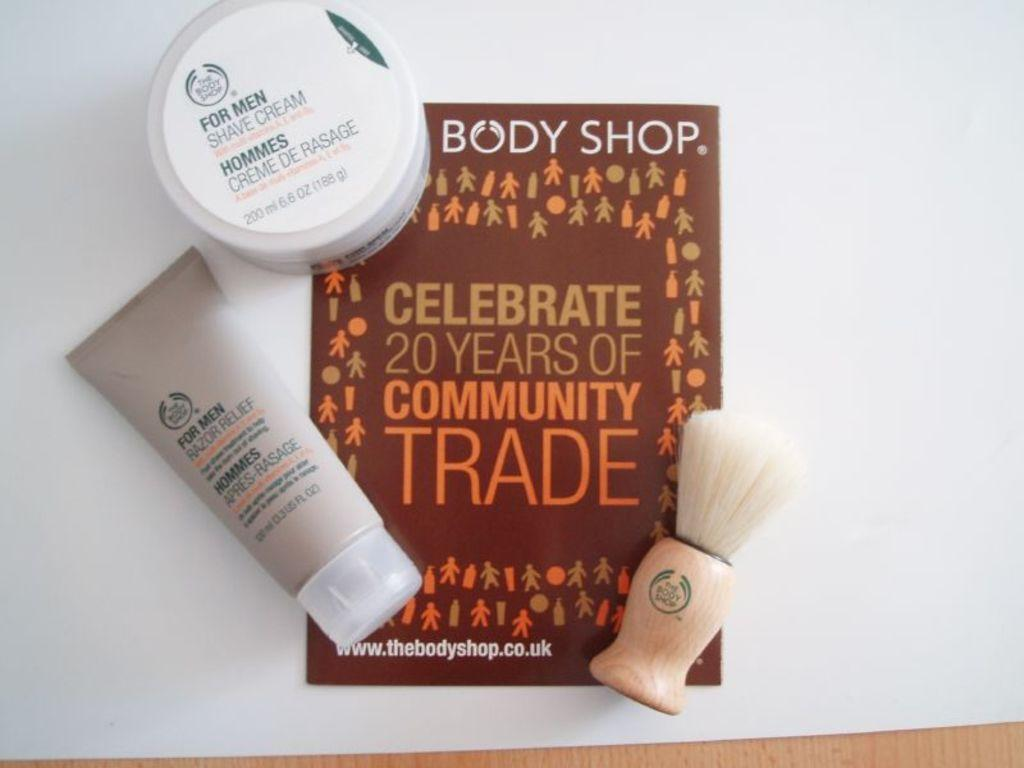<image>
Offer a succinct explanation of the picture presented. Some Body Shop items which are celebrating '20 years of community trade.' 